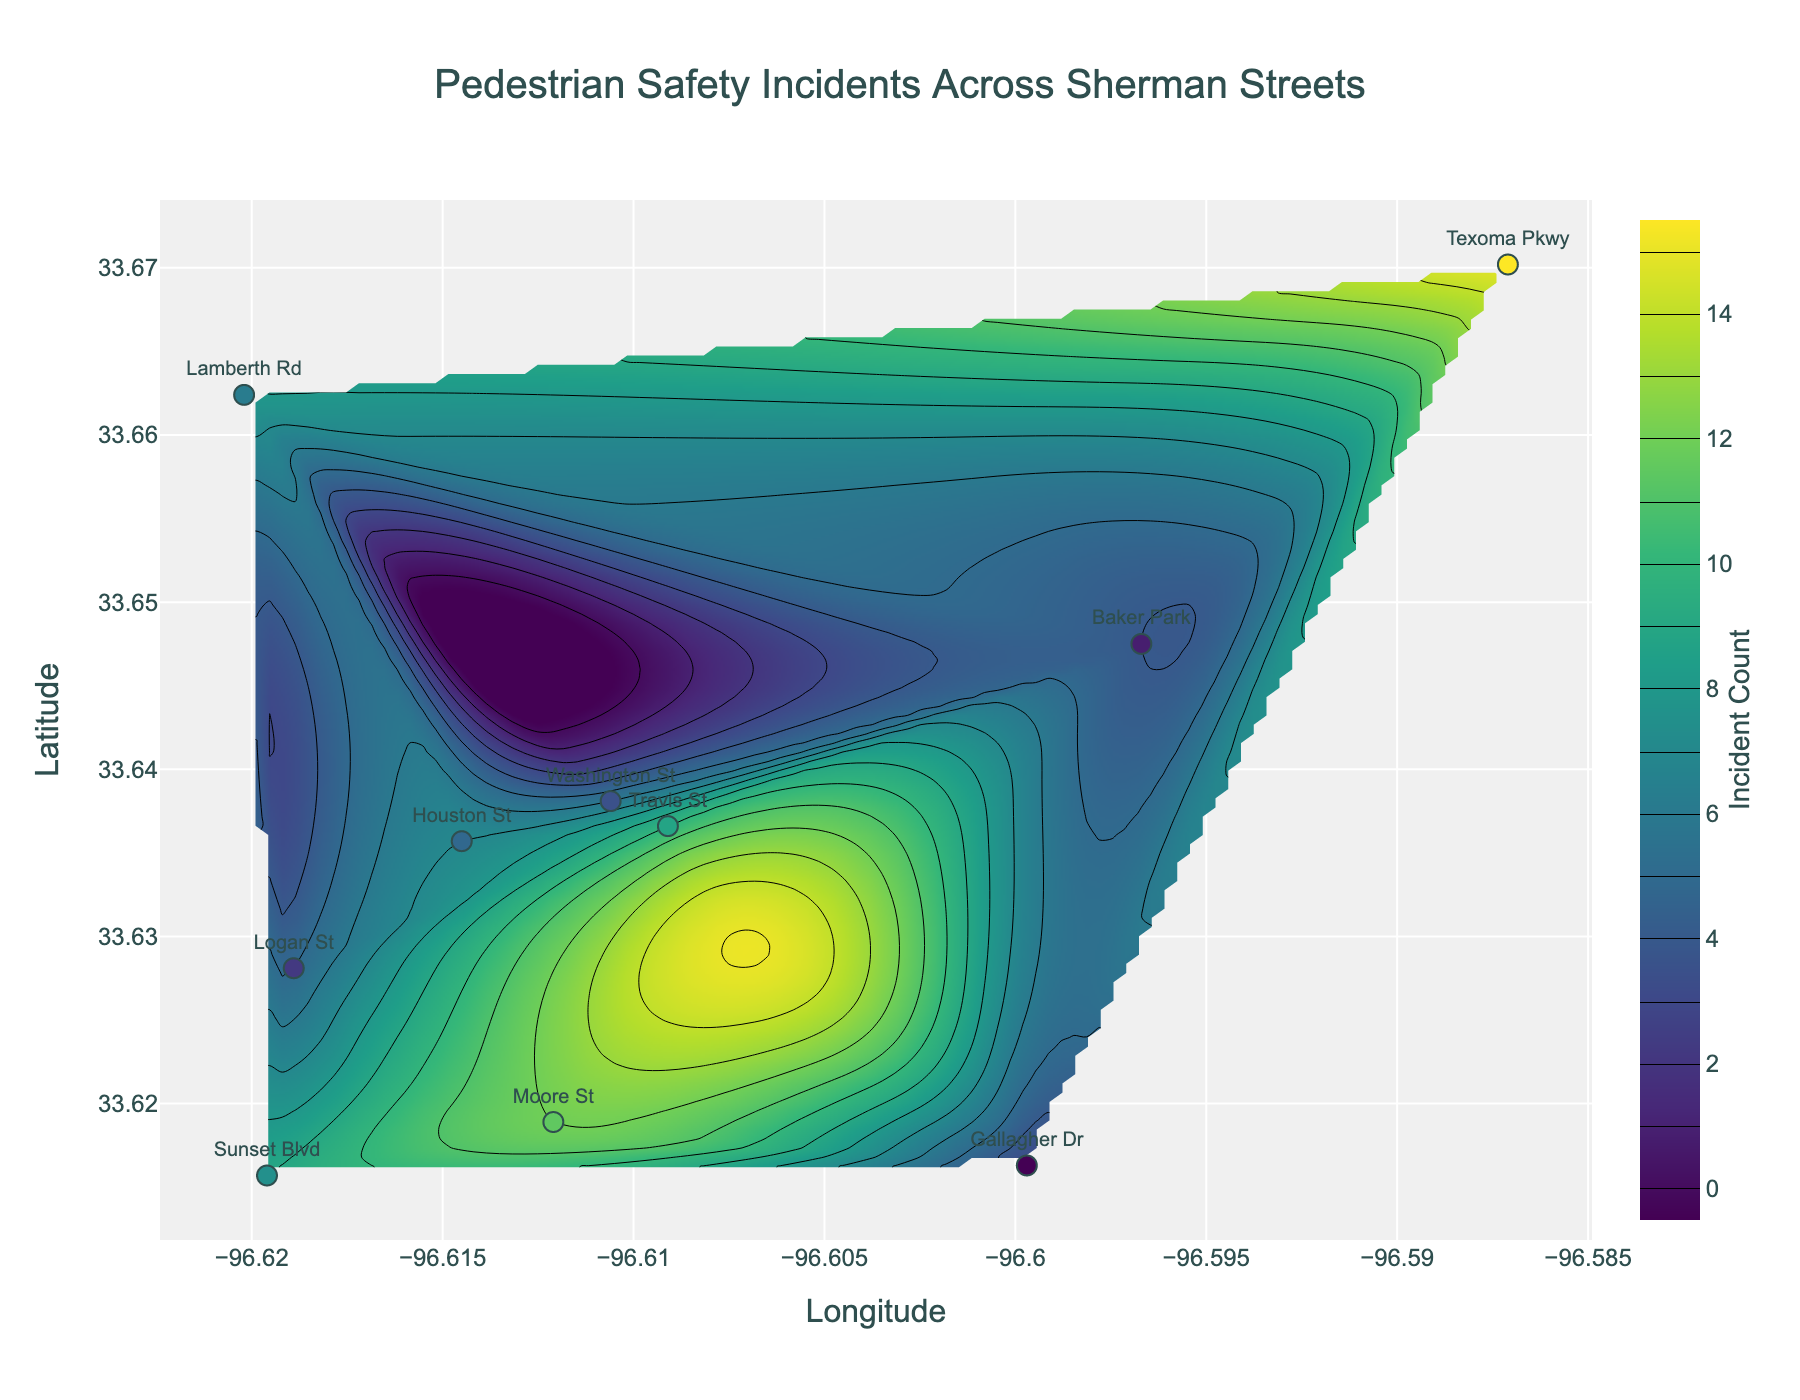What is the title of the figure? The title is displayed at the top of the figure, often in a larger and bold font, to describe what the plot is about. Here, it clearly states "Pedestrian Safety Incidents Across Sherman Streets".
Answer: Pedestrian Safety Incidents Across Sherman Streets Which street has the highest number of pedestrian safety incidents? To determine this, look for the highest colored contour region and its corresponding street name from the markers. The darkest color in the contour represents the highest incident count, which is labeled as Texoma Pkwy with 15 incidents.
Answer: Texoma Pkwy How many pedestrian safety incidents are recorded on Travis St? Check the label for Travis St on the scatter plot and look at the incident count associated with it, which is shown as a marker labeled "10" on Travis St.
Answer: 10 What are the coordinates (Latitude and Longitude) for the point with the highest incident count? Locate the point on the plot with the darkest color and highest marker count in the scatter plot. This point corresponds to Texoma Pkwy at coordinates (33.6702, -96.5871).
Answer: (33.6702, -96.5871) Which street experiences fewer pedestrian safety incidents: Logan St or Gallagher Dr? Compare the incident counts labeled on both streets' markers. Logan St shows 5 incidents, while Gallagher Dr shows 3 incidents.
Answer: Gallagher Dr What is the range of the longitude axis displayed in the plot? The range of the longitude axis is found at the bottom of the plot along the horizontal direction. The minimum longitude value is approximately -96.620 and the maximum is -96.587.
Answer: Approximately -96.620 to -96.587 Which streets have fewer than 7 pedestrian safety incidents? Identify markers with counts less than 7: Washington St (6), Baker Park (4), Logan St (5), and Gallagher Dr (3).
Answer: Washington St, Baker Park, Logan St, Gallagher Dr Compare the pedestrian safety incidents between Sunset Blvd and Moore St. Which has more incidents? Check the incident counts on the markers for both streets. Sunset Blvd has 9 incidents, while Moore St has 12 incidents.
Answer: Moore St Which area in the plot shows the highest concentration of incidents according to the contour shading? Areas with the darkest shading in the contour plot indicate the highest concentration of incidents. This region is centered around the coordinates of Texoma Pkwy, where the incident count is highest.
Answer: Texoma Pkwy area What is the incident count at Houston St and how does it compare to Lamberth Rd? Check the incident counts next to the markers for both streets: Houston St has 7 incidents and Lamberth Rd has 8 incidents.
Answer: Houston St has 1 less incident than Lamberth Rd 